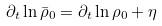<formula> <loc_0><loc_0><loc_500><loc_500>\partial _ { t } \ln \bar { \rho } _ { 0 } = \partial _ { t } \ln \rho _ { 0 } + \eta</formula> 